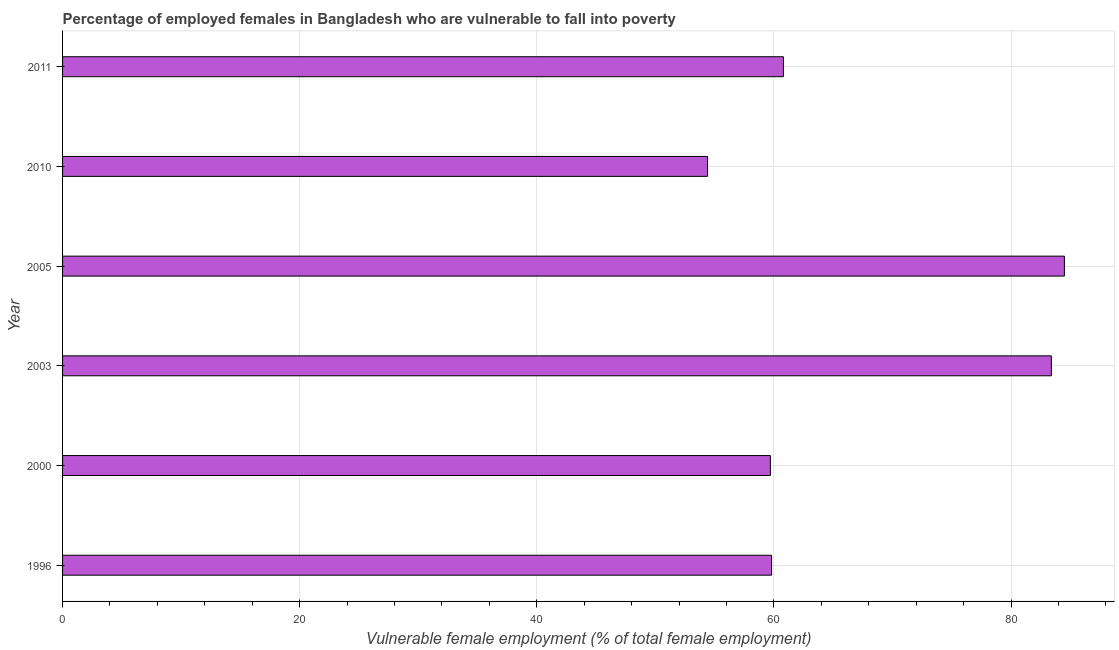Does the graph contain grids?
Your answer should be very brief. Yes. What is the title of the graph?
Provide a short and direct response. Percentage of employed females in Bangladesh who are vulnerable to fall into poverty. What is the label or title of the X-axis?
Offer a terse response. Vulnerable female employment (% of total female employment). What is the percentage of employed females who are vulnerable to fall into poverty in 2011?
Give a very brief answer. 60.8. Across all years, what is the maximum percentage of employed females who are vulnerable to fall into poverty?
Offer a very short reply. 84.5. Across all years, what is the minimum percentage of employed females who are vulnerable to fall into poverty?
Keep it short and to the point. 54.4. What is the sum of the percentage of employed females who are vulnerable to fall into poverty?
Your answer should be very brief. 402.6. What is the difference between the percentage of employed females who are vulnerable to fall into poverty in 1996 and 2005?
Your answer should be compact. -24.7. What is the average percentage of employed females who are vulnerable to fall into poverty per year?
Your answer should be very brief. 67.1. What is the median percentage of employed females who are vulnerable to fall into poverty?
Provide a short and direct response. 60.3. What is the ratio of the percentage of employed females who are vulnerable to fall into poverty in 2005 to that in 2011?
Offer a terse response. 1.39. Is the difference between the percentage of employed females who are vulnerable to fall into poverty in 2003 and 2005 greater than the difference between any two years?
Your answer should be very brief. No. What is the difference between the highest and the lowest percentage of employed females who are vulnerable to fall into poverty?
Keep it short and to the point. 30.1. In how many years, is the percentage of employed females who are vulnerable to fall into poverty greater than the average percentage of employed females who are vulnerable to fall into poverty taken over all years?
Provide a short and direct response. 2. Are all the bars in the graph horizontal?
Offer a very short reply. Yes. What is the difference between two consecutive major ticks on the X-axis?
Keep it short and to the point. 20. Are the values on the major ticks of X-axis written in scientific E-notation?
Your response must be concise. No. What is the Vulnerable female employment (% of total female employment) in 1996?
Keep it short and to the point. 59.8. What is the Vulnerable female employment (% of total female employment) of 2000?
Keep it short and to the point. 59.7. What is the Vulnerable female employment (% of total female employment) in 2003?
Offer a terse response. 83.4. What is the Vulnerable female employment (% of total female employment) of 2005?
Give a very brief answer. 84.5. What is the Vulnerable female employment (% of total female employment) in 2010?
Make the answer very short. 54.4. What is the Vulnerable female employment (% of total female employment) of 2011?
Give a very brief answer. 60.8. What is the difference between the Vulnerable female employment (% of total female employment) in 1996 and 2003?
Ensure brevity in your answer.  -23.6. What is the difference between the Vulnerable female employment (% of total female employment) in 1996 and 2005?
Keep it short and to the point. -24.7. What is the difference between the Vulnerable female employment (% of total female employment) in 1996 and 2010?
Give a very brief answer. 5.4. What is the difference between the Vulnerable female employment (% of total female employment) in 2000 and 2003?
Make the answer very short. -23.7. What is the difference between the Vulnerable female employment (% of total female employment) in 2000 and 2005?
Provide a short and direct response. -24.8. What is the difference between the Vulnerable female employment (% of total female employment) in 2000 and 2010?
Ensure brevity in your answer.  5.3. What is the difference between the Vulnerable female employment (% of total female employment) in 2000 and 2011?
Offer a terse response. -1.1. What is the difference between the Vulnerable female employment (% of total female employment) in 2003 and 2010?
Give a very brief answer. 29. What is the difference between the Vulnerable female employment (% of total female employment) in 2003 and 2011?
Provide a succinct answer. 22.6. What is the difference between the Vulnerable female employment (% of total female employment) in 2005 and 2010?
Ensure brevity in your answer.  30.1. What is the difference between the Vulnerable female employment (% of total female employment) in 2005 and 2011?
Keep it short and to the point. 23.7. What is the ratio of the Vulnerable female employment (% of total female employment) in 1996 to that in 2000?
Your answer should be very brief. 1. What is the ratio of the Vulnerable female employment (% of total female employment) in 1996 to that in 2003?
Keep it short and to the point. 0.72. What is the ratio of the Vulnerable female employment (% of total female employment) in 1996 to that in 2005?
Keep it short and to the point. 0.71. What is the ratio of the Vulnerable female employment (% of total female employment) in 1996 to that in 2010?
Provide a succinct answer. 1.1. What is the ratio of the Vulnerable female employment (% of total female employment) in 1996 to that in 2011?
Offer a very short reply. 0.98. What is the ratio of the Vulnerable female employment (% of total female employment) in 2000 to that in 2003?
Ensure brevity in your answer.  0.72. What is the ratio of the Vulnerable female employment (% of total female employment) in 2000 to that in 2005?
Your answer should be very brief. 0.71. What is the ratio of the Vulnerable female employment (% of total female employment) in 2000 to that in 2010?
Give a very brief answer. 1.1. What is the ratio of the Vulnerable female employment (% of total female employment) in 2003 to that in 2005?
Your response must be concise. 0.99. What is the ratio of the Vulnerable female employment (% of total female employment) in 2003 to that in 2010?
Offer a terse response. 1.53. What is the ratio of the Vulnerable female employment (% of total female employment) in 2003 to that in 2011?
Keep it short and to the point. 1.37. What is the ratio of the Vulnerable female employment (% of total female employment) in 2005 to that in 2010?
Offer a very short reply. 1.55. What is the ratio of the Vulnerable female employment (% of total female employment) in 2005 to that in 2011?
Provide a succinct answer. 1.39. What is the ratio of the Vulnerable female employment (% of total female employment) in 2010 to that in 2011?
Your answer should be very brief. 0.9. 